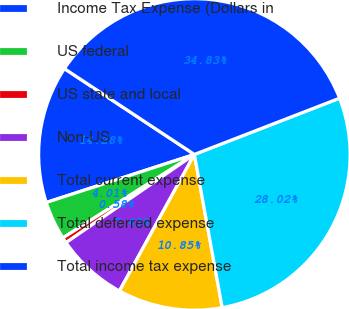<chart> <loc_0><loc_0><loc_500><loc_500><pie_chart><fcel>Income Tax Expense (Dollars in<fcel>US federal<fcel>US state and local<fcel>Non-US<fcel>Total current expense<fcel>Total deferred expense<fcel>Total income tax expense<nl><fcel>14.28%<fcel>4.01%<fcel>0.58%<fcel>7.43%<fcel>10.85%<fcel>28.02%<fcel>34.83%<nl></chart> 